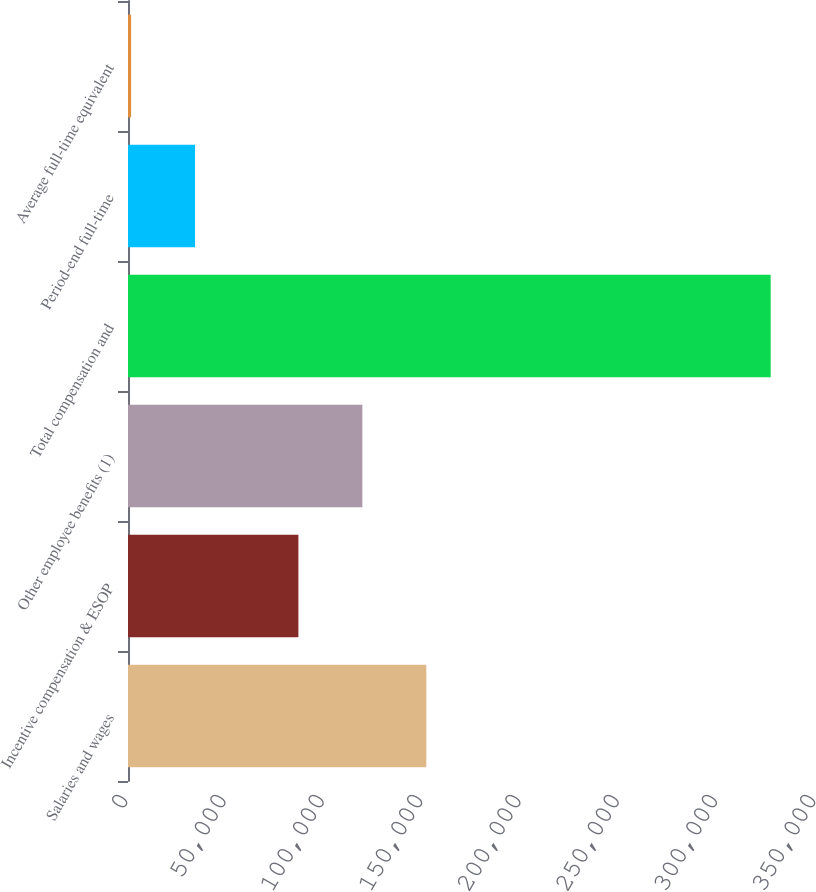<chart> <loc_0><loc_0><loc_500><loc_500><bar_chart><fcel>Salaries and wages<fcel>Incentive compensation & ESOP<fcel>Other employee benefits (1)<fcel>Total compensation and<fcel>Period-end full-time<fcel>Average full-time equivalent<nl><fcel>151756<fcel>86684<fcel>119220<fcel>326942<fcel>34117.1<fcel>1581<nl></chart> 